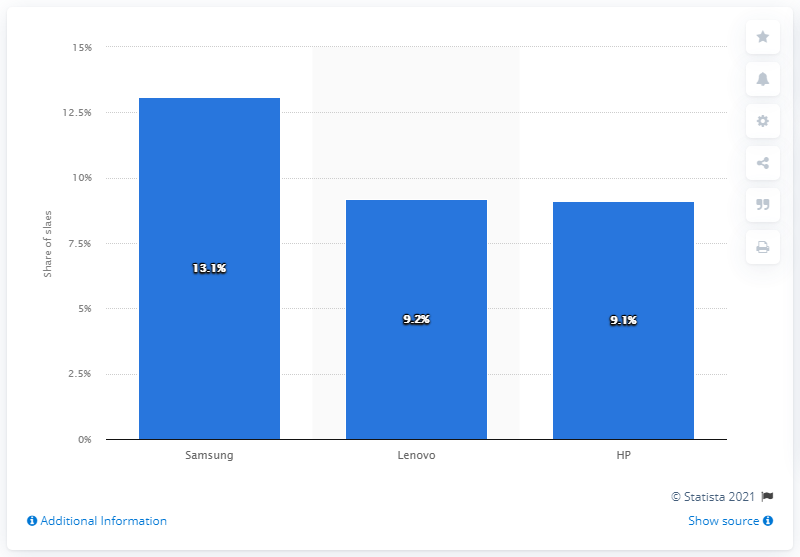Specify some key components in this picture. According to estimates, Samsung was expected to hold more than 13 percent of the Latin American computer market in 2017. 